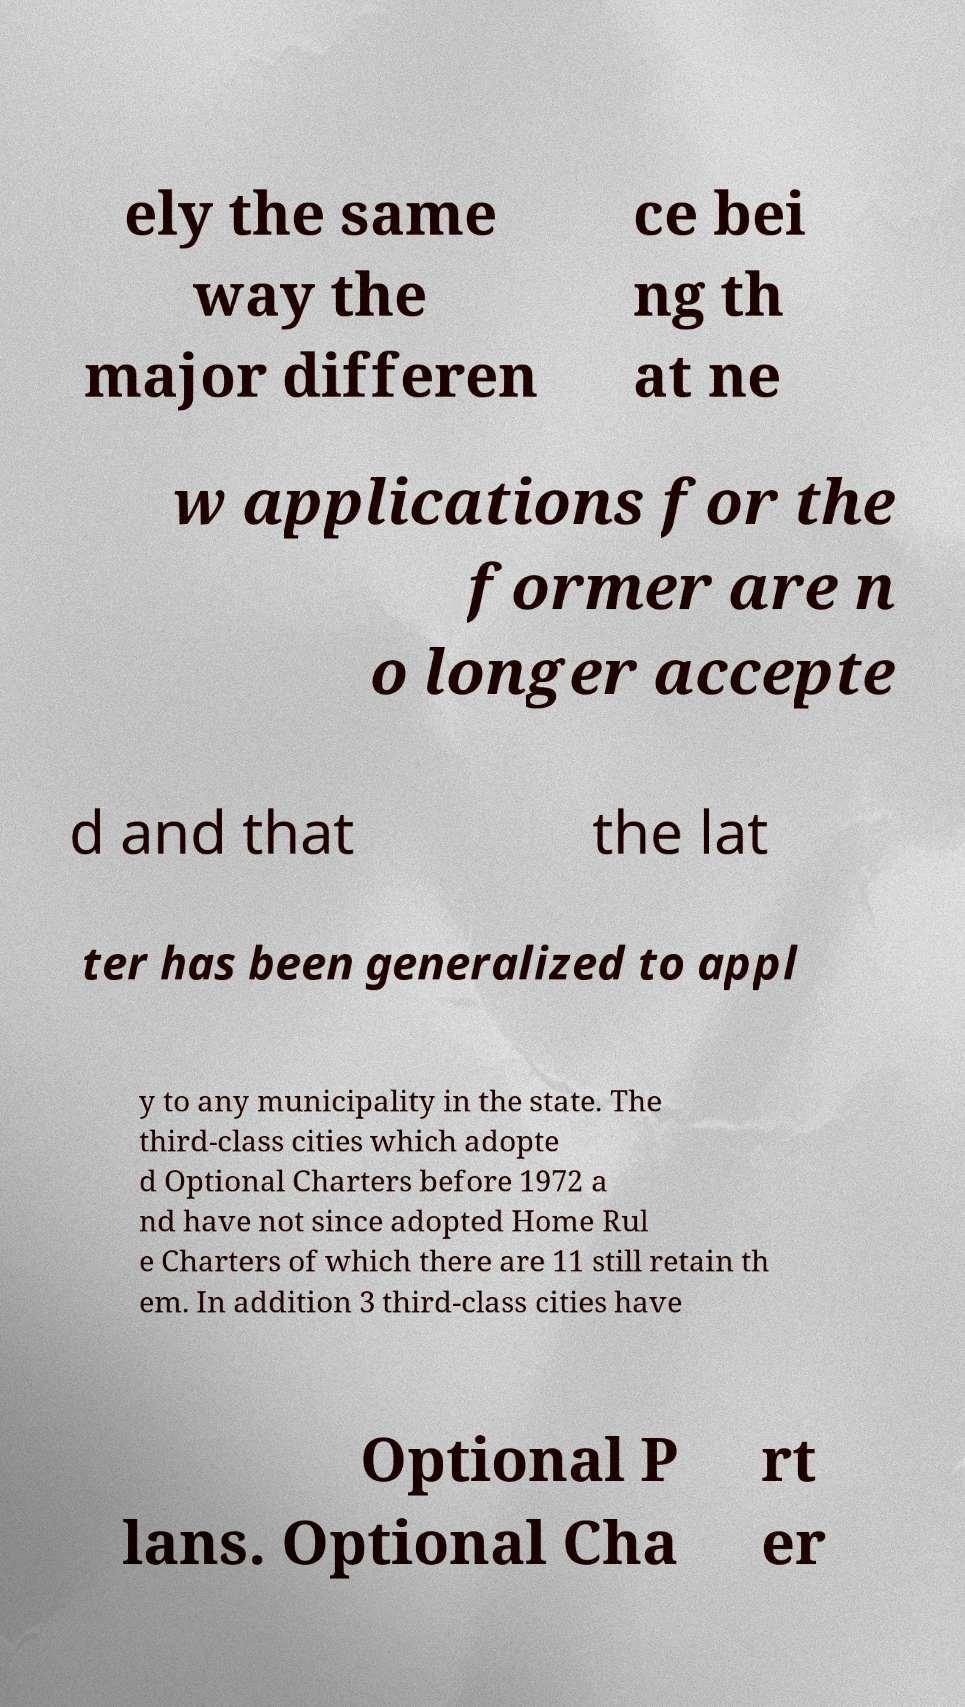Could you assist in decoding the text presented in this image and type it out clearly? ely the same way the major differen ce bei ng th at ne w applications for the former are n o longer accepte d and that the lat ter has been generalized to appl y to any municipality in the state. The third-class cities which adopte d Optional Charters before 1972 a nd have not since adopted Home Rul e Charters of which there are 11 still retain th em. In addition 3 third-class cities have Optional P lans. Optional Cha rt er 